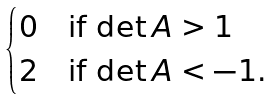<formula> <loc_0><loc_0><loc_500><loc_500>\begin{cases} 0 & \text {if $\det A>1$} \\ 2 & \text {if $\det A<-1$.} \end{cases}</formula> 